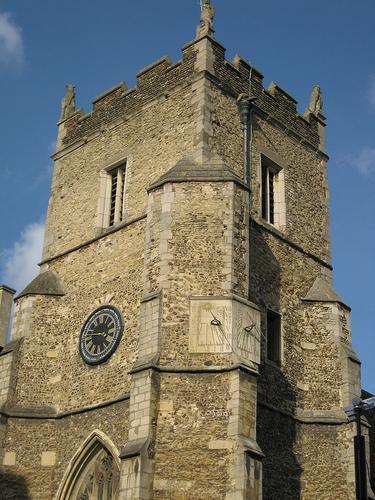How many windows can be seen?
Give a very brief answer. 3. 